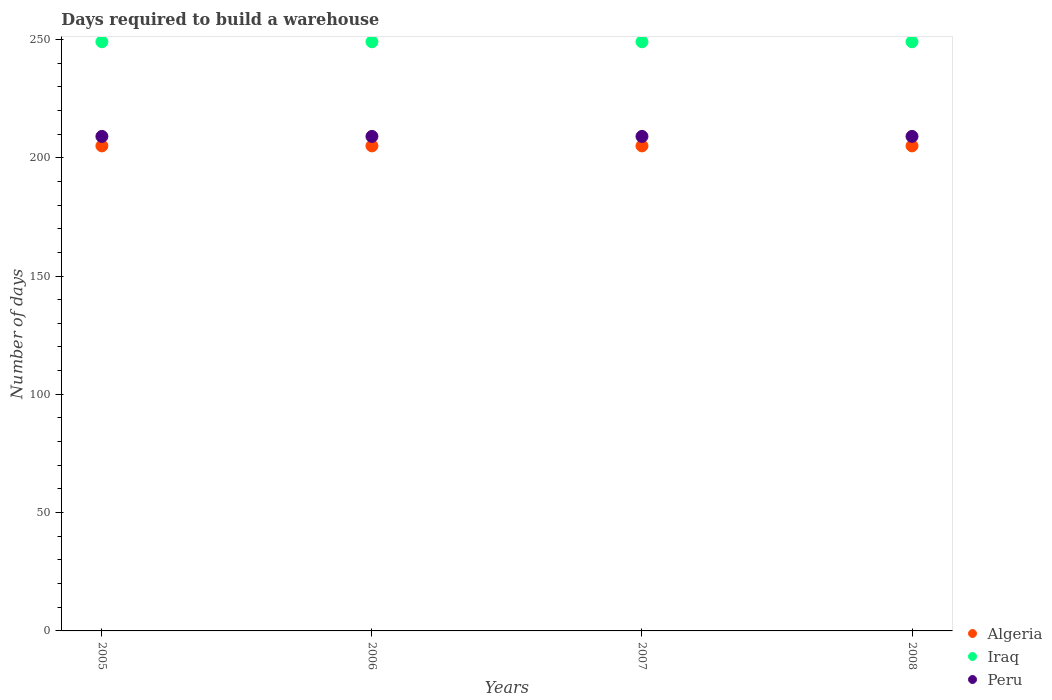What is the days required to build a warehouse in in Algeria in 2006?
Ensure brevity in your answer.  205. Across all years, what is the maximum days required to build a warehouse in in Algeria?
Offer a terse response. 205. Across all years, what is the minimum days required to build a warehouse in in Iraq?
Your answer should be compact. 249. What is the total days required to build a warehouse in in Peru in the graph?
Make the answer very short. 836. What is the difference between the days required to build a warehouse in in Peru in 2005 and the days required to build a warehouse in in Iraq in 2007?
Offer a terse response. -40. What is the average days required to build a warehouse in in Iraq per year?
Ensure brevity in your answer.  249. In the year 2006, what is the difference between the days required to build a warehouse in in Peru and days required to build a warehouse in in Iraq?
Provide a succinct answer. -40. In how many years, is the days required to build a warehouse in in Peru greater than 10 days?
Your answer should be compact. 4. Is the days required to build a warehouse in in Iraq in 2007 less than that in 2008?
Provide a short and direct response. No. Is the difference between the days required to build a warehouse in in Peru in 2006 and 2007 greater than the difference between the days required to build a warehouse in in Iraq in 2006 and 2007?
Your answer should be compact. No. What is the difference between the highest and the lowest days required to build a warehouse in in Iraq?
Offer a very short reply. 0. Is the sum of the days required to build a warehouse in in Peru in 2005 and 2007 greater than the maximum days required to build a warehouse in in Iraq across all years?
Provide a succinct answer. Yes. Is it the case that in every year, the sum of the days required to build a warehouse in in Iraq and days required to build a warehouse in in Peru  is greater than the days required to build a warehouse in in Algeria?
Keep it short and to the point. Yes. Does the days required to build a warehouse in in Algeria monotonically increase over the years?
Your response must be concise. No. Is the days required to build a warehouse in in Iraq strictly greater than the days required to build a warehouse in in Peru over the years?
Offer a very short reply. Yes. How many dotlines are there?
Offer a terse response. 3. How many years are there in the graph?
Ensure brevity in your answer.  4. What is the difference between two consecutive major ticks on the Y-axis?
Offer a terse response. 50. Are the values on the major ticks of Y-axis written in scientific E-notation?
Give a very brief answer. No. Does the graph contain any zero values?
Provide a succinct answer. No. Does the graph contain grids?
Offer a terse response. No. Where does the legend appear in the graph?
Keep it short and to the point. Bottom right. How many legend labels are there?
Provide a short and direct response. 3. How are the legend labels stacked?
Your answer should be compact. Vertical. What is the title of the graph?
Offer a very short reply. Days required to build a warehouse. Does "Iran" appear as one of the legend labels in the graph?
Make the answer very short. No. What is the label or title of the Y-axis?
Your response must be concise. Number of days. What is the Number of days in Algeria in 2005?
Your answer should be very brief. 205. What is the Number of days of Iraq in 2005?
Your answer should be very brief. 249. What is the Number of days of Peru in 2005?
Keep it short and to the point. 209. What is the Number of days in Algeria in 2006?
Your response must be concise. 205. What is the Number of days in Iraq in 2006?
Your response must be concise. 249. What is the Number of days of Peru in 2006?
Your answer should be compact. 209. What is the Number of days in Algeria in 2007?
Offer a terse response. 205. What is the Number of days in Iraq in 2007?
Your answer should be very brief. 249. What is the Number of days in Peru in 2007?
Ensure brevity in your answer.  209. What is the Number of days in Algeria in 2008?
Provide a short and direct response. 205. What is the Number of days in Iraq in 2008?
Your response must be concise. 249. What is the Number of days of Peru in 2008?
Offer a terse response. 209. Across all years, what is the maximum Number of days in Algeria?
Provide a succinct answer. 205. Across all years, what is the maximum Number of days of Iraq?
Offer a terse response. 249. Across all years, what is the maximum Number of days in Peru?
Make the answer very short. 209. Across all years, what is the minimum Number of days in Algeria?
Your answer should be compact. 205. Across all years, what is the minimum Number of days in Iraq?
Make the answer very short. 249. Across all years, what is the minimum Number of days in Peru?
Provide a short and direct response. 209. What is the total Number of days in Algeria in the graph?
Your answer should be compact. 820. What is the total Number of days in Iraq in the graph?
Ensure brevity in your answer.  996. What is the total Number of days of Peru in the graph?
Keep it short and to the point. 836. What is the difference between the Number of days in Peru in 2005 and that in 2006?
Keep it short and to the point. 0. What is the difference between the Number of days in Iraq in 2005 and that in 2007?
Your answer should be very brief. 0. What is the difference between the Number of days in Algeria in 2005 and that in 2008?
Provide a short and direct response. 0. What is the difference between the Number of days of Iraq in 2006 and that in 2007?
Provide a succinct answer. 0. What is the difference between the Number of days in Peru in 2006 and that in 2007?
Your answer should be compact. 0. What is the difference between the Number of days of Algeria in 2006 and that in 2008?
Your answer should be very brief. 0. What is the difference between the Number of days in Iraq in 2006 and that in 2008?
Provide a succinct answer. 0. What is the difference between the Number of days of Peru in 2006 and that in 2008?
Offer a terse response. 0. What is the difference between the Number of days of Algeria in 2005 and the Number of days of Iraq in 2006?
Your answer should be compact. -44. What is the difference between the Number of days in Algeria in 2005 and the Number of days in Peru in 2006?
Keep it short and to the point. -4. What is the difference between the Number of days in Algeria in 2005 and the Number of days in Iraq in 2007?
Your answer should be very brief. -44. What is the difference between the Number of days of Iraq in 2005 and the Number of days of Peru in 2007?
Offer a terse response. 40. What is the difference between the Number of days in Algeria in 2005 and the Number of days in Iraq in 2008?
Your response must be concise. -44. What is the difference between the Number of days in Algeria in 2006 and the Number of days in Iraq in 2007?
Provide a succinct answer. -44. What is the difference between the Number of days in Algeria in 2006 and the Number of days in Peru in 2007?
Offer a very short reply. -4. What is the difference between the Number of days of Iraq in 2006 and the Number of days of Peru in 2007?
Provide a short and direct response. 40. What is the difference between the Number of days in Algeria in 2006 and the Number of days in Iraq in 2008?
Provide a short and direct response. -44. What is the difference between the Number of days in Algeria in 2006 and the Number of days in Peru in 2008?
Your answer should be compact. -4. What is the difference between the Number of days in Algeria in 2007 and the Number of days in Iraq in 2008?
Offer a very short reply. -44. What is the difference between the Number of days in Iraq in 2007 and the Number of days in Peru in 2008?
Keep it short and to the point. 40. What is the average Number of days of Algeria per year?
Make the answer very short. 205. What is the average Number of days in Iraq per year?
Provide a succinct answer. 249. What is the average Number of days in Peru per year?
Your answer should be very brief. 209. In the year 2005, what is the difference between the Number of days in Algeria and Number of days in Iraq?
Your answer should be very brief. -44. In the year 2005, what is the difference between the Number of days in Algeria and Number of days in Peru?
Ensure brevity in your answer.  -4. In the year 2006, what is the difference between the Number of days of Algeria and Number of days of Iraq?
Provide a succinct answer. -44. In the year 2006, what is the difference between the Number of days in Algeria and Number of days in Peru?
Your response must be concise. -4. In the year 2007, what is the difference between the Number of days in Algeria and Number of days in Iraq?
Your response must be concise. -44. In the year 2007, what is the difference between the Number of days in Iraq and Number of days in Peru?
Offer a terse response. 40. In the year 2008, what is the difference between the Number of days of Algeria and Number of days of Iraq?
Ensure brevity in your answer.  -44. What is the ratio of the Number of days of Iraq in 2005 to that in 2006?
Make the answer very short. 1. What is the ratio of the Number of days of Peru in 2005 to that in 2006?
Ensure brevity in your answer.  1. What is the ratio of the Number of days in Algeria in 2005 to that in 2007?
Give a very brief answer. 1. What is the ratio of the Number of days of Algeria in 2005 to that in 2008?
Provide a short and direct response. 1. What is the ratio of the Number of days of Algeria in 2006 to that in 2007?
Offer a terse response. 1. What is the ratio of the Number of days in Peru in 2006 to that in 2007?
Give a very brief answer. 1. What is the ratio of the Number of days of Peru in 2006 to that in 2008?
Make the answer very short. 1. What is the difference between the highest and the second highest Number of days of Iraq?
Your answer should be compact. 0. 